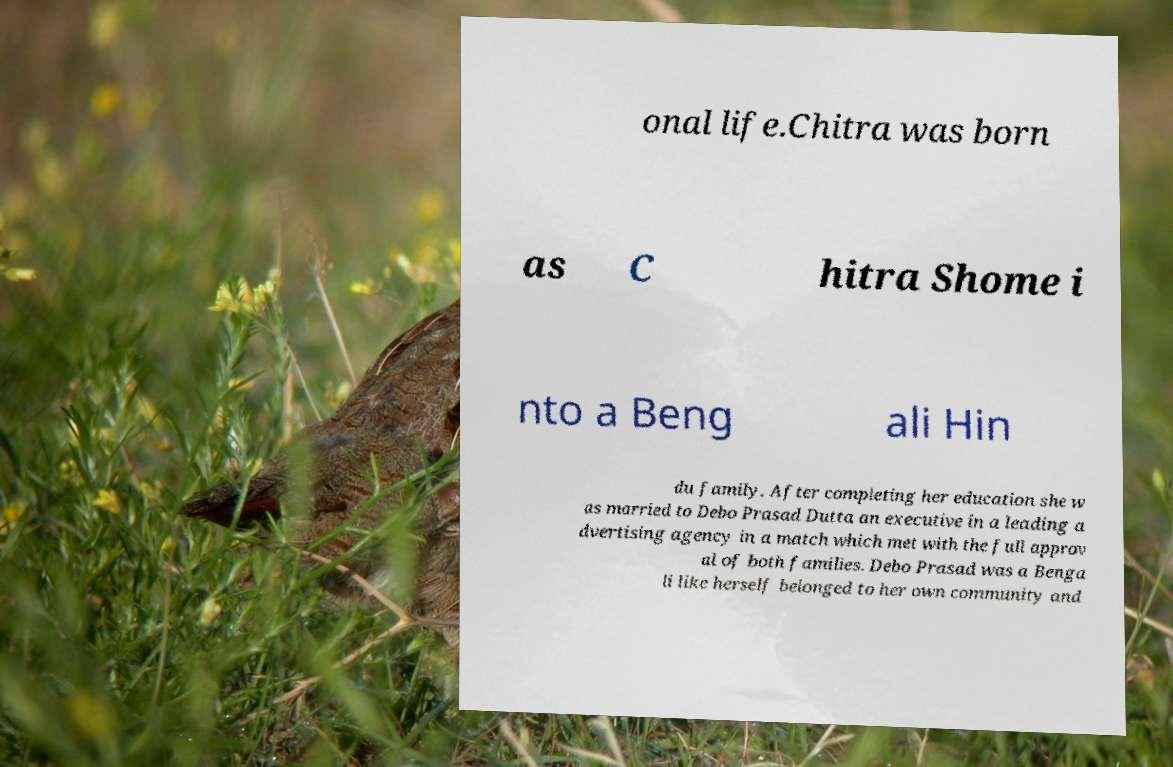What messages or text are displayed in this image? I need them in a readable, typed format. onal life.Chitra was born as C hitra Shome i nto a Beng ali Hin du family. After completing her education she w as married to Debo Prasad Dutta an executive in a leading a dvertising agency in a match which met with the full approv al of both families. Debo Prasad was a Benga li like herself belonged to her own community and 